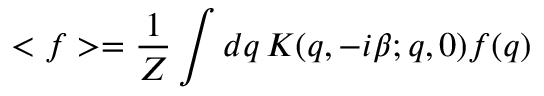<formula> <loc_0><loc_0><loc_500><loc_500>< f > = \frac { 1 } { Z } \int d q \, K ( q , - i \beta ; q , 0 ) f ( q )</formula> 